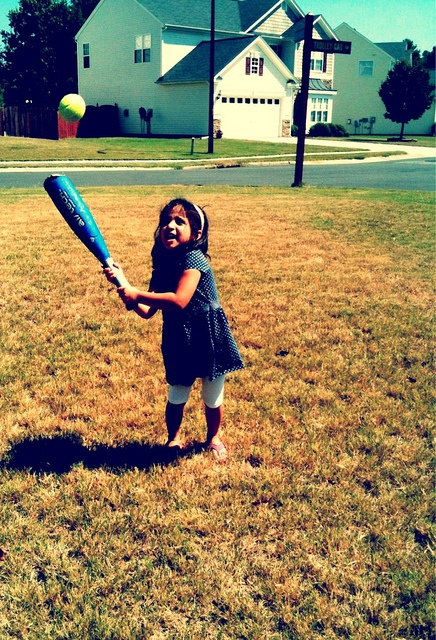Describe the objects in this image and their specific colors. I can see people in turquoise, navy, tan, and gray tones, baseball bat in turquoise, navy, and lightyellow tones, and sports ball in turquoise, darkgreen, lightyellow, yellow, and khaki tones in this image. 